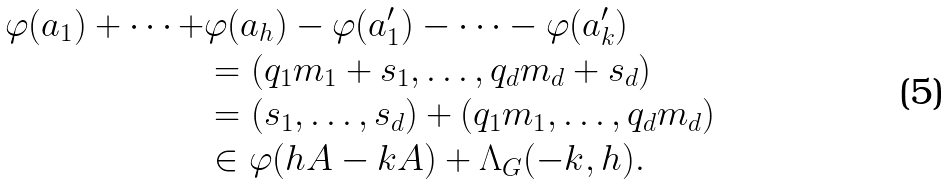<formula> <loc_0><loc_0><loc_500><loc_500>\varphi ( a _ { 1 } ) + \cdots + & \varphi ( a _ { h } ) - \varphi ( a ^ { \prime } _ { 1 } ) - \cdots - \varphi ( a ^ { \prime } _ { k } ) \\ & = ( q _ { 1 } m _ { 1 } + s _ { 1 } , \dots , q _ { d } m _ { d } + s _ { d } ) \\ & = ( s _ { 1 } , \dots , s _ { d } ) + ( q _ { 1 } m _ { 1 } , \dots , q _ { d } m _ { d } ) \\ & \in \varphi ( h A - k A ) + \Lambda _ { G } ( - k , h ) .</formula> 